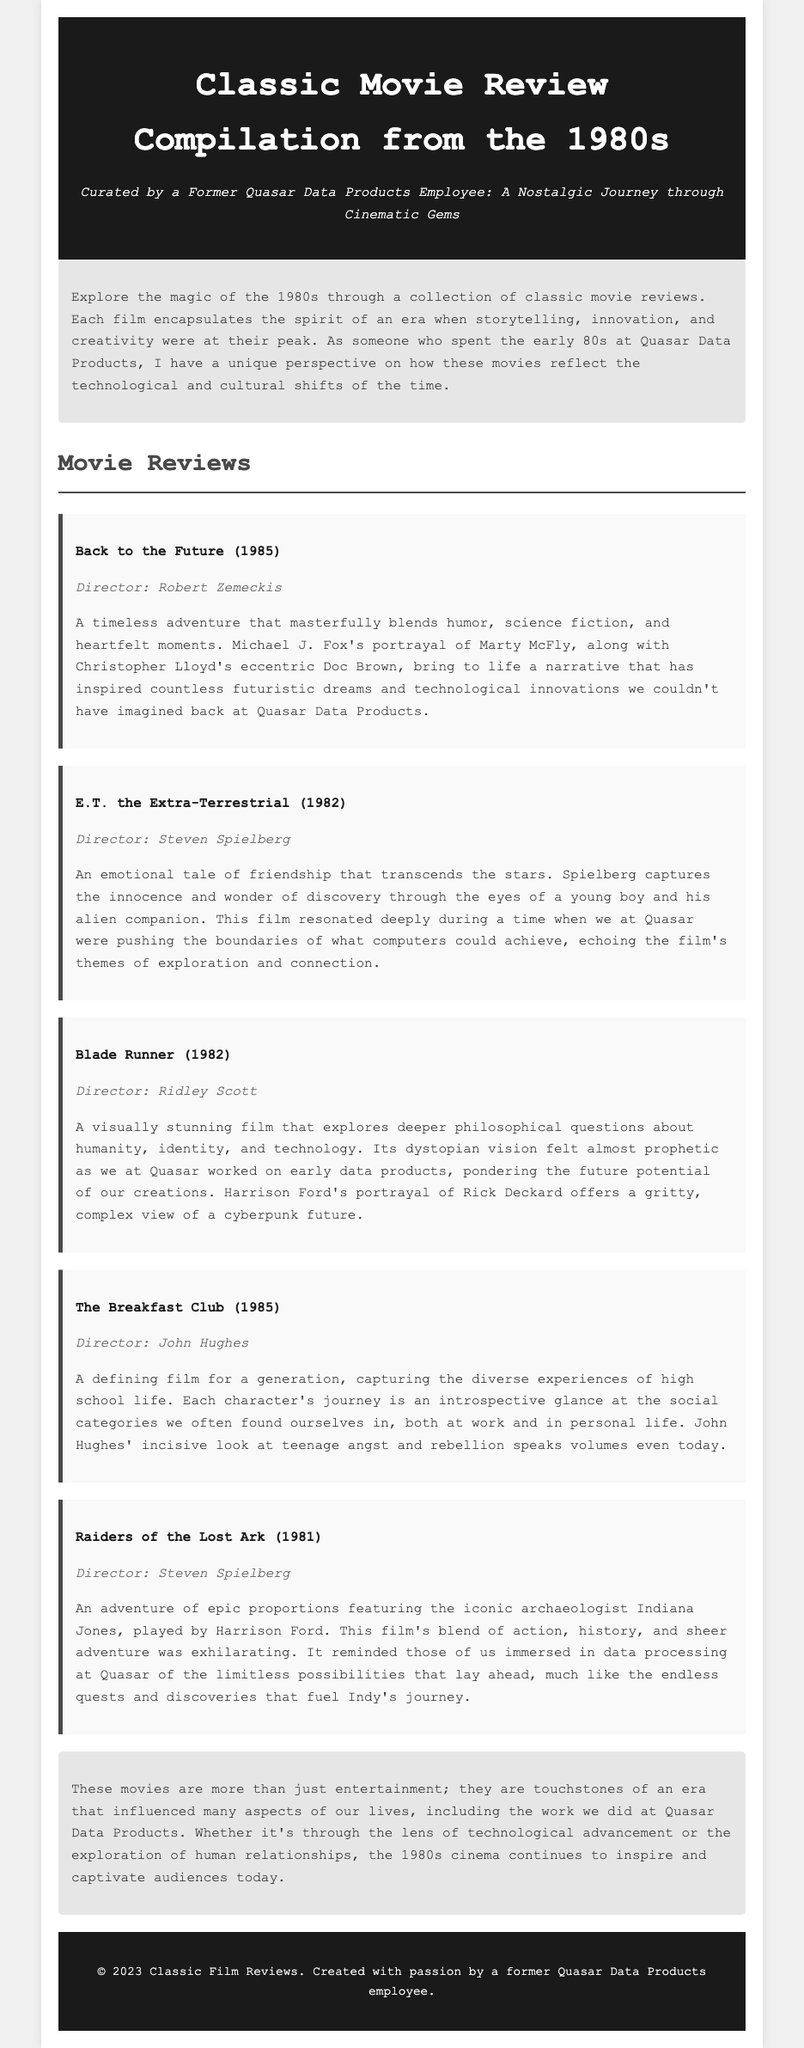What is the title of the compilation? The document's main title, prominently displayed in the header, identifies the subject matter.
Answer: Classic Movie Review Compilation from the 1980s Who directed "E.T. the Extra-Terrestrial"? The document specifically notes the director's name alongside the film title in the movie review section.
Answer: Steven Spielberg What year was "Back to the Future" released? The year of release is mentioned directly after the film title in parentheses.
Answer: 1985 Which movie features the character Indiana Jones? The content about the movie includes details about the iconic character connected to the film title.
Answer: Raiders of the Lost Ark What genre does "Blade Runner" primarily explore? The review discusses the film's focus on philosophical questions, highlighting its thematic depth.
Answer: Humanity, identity, and technology How many movie reviews are included in the compilation? The number of reviews is inferred from the distinct sections in the document, each designated for a movie.
Answer: Five What theme does "The Breakfast Club" focus on? The review highlights social categories and teenage experiences as central elements of the film's narrative.
Answer: High school life What emotion is primarily portrayed in "E.T. the Extra-Terrestrial"? The summary reflects on the connection between characters, pointing to a significant emotion depicted in the film.
Answer: Friendship 